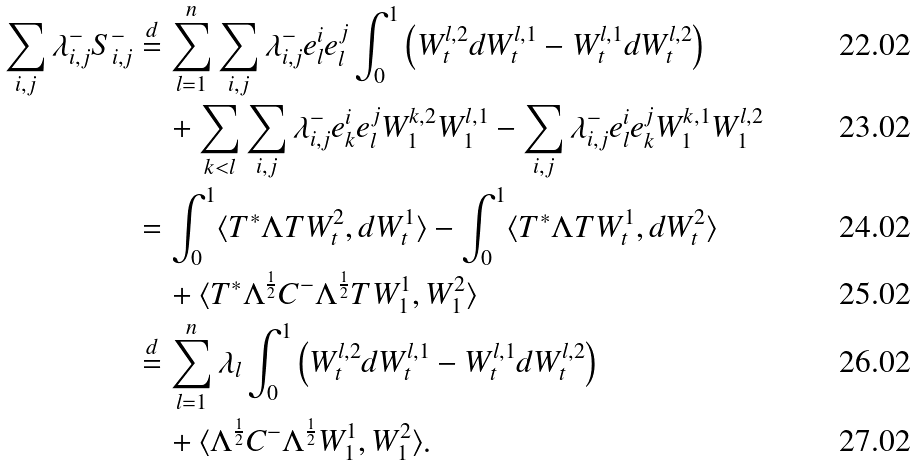<formula> <loc_0><loc_0><loc_500><loc_500>\sum _ { i , j } \lambda ^ { - } _ { i , j } S _ { i , j } ^ { - } & \overset { d } { = } \sum _ { l = 1 } ^ { n } \sum _ { i , j } \lambda ^ { - } _ { i , j } e ^ { i } _ { l } e ^ { j } _ { l } \int _ { 0 } ^ { 1 } \left ( W _ { t } ^ { l , 2 } d W _ { t } ^ { l , 1 } - W _ { t } ^ { l , 1 } d W _ { t } ^ { l , 2 } \right ) \\ & \quad + \sum _ { k < l } \sum _ { i , j } \lambda ^ { - } _ { i , j } e ^ { i } _ { k } e ^ { j } _ { l } W ^ { k , 2 } _ { 1 } W ^ { l , 1 } _ { 1 } - \sum _ { i , j } \lambda ^ { - } _ { i , j } e ^ { i } _ { l } e ^ { j } _ { k } W ^ { k , 1 } _ { 1 } W _ { 1 } ^ { l , 2 } \\ & = \int _ { 0 } ^ { 1 } \langle T ^ { * } \Lambda T W _ { t } ^ { 2 } , d W _ { t } ^ { 1 } \rangle - \int _ { 0 } ^ { 1 } \langle T ^ { * } \Lambda T W _ { t } ^ { 1 } , d W _ { t } ^ { 2 } \rangle \\ & \quad + \langle T ^ { * } \Lambda ^ { \frac { 1 } { 2 } } C ^ { - } \Lambda ^ { \frac { 1 } { 2 } } T W ^ { 1 } _ { 1 } , W ^ { 2 } _ { 1 } \rangle \\ & \overset { d } { = } \sum _ { l = 1 } ^ { n } \lambda _ { l } \int _ { 0 } ^ { 1 } \left ( W _ { t } ^ { l , 2 } d W _ { t } ^ { l , 1 } - W _ { t } ^ { l , 1 } d W _ { t } ^ { l , 2 } \right ) \\ & \quad + \langle \Lambda ^ { \frac { 1 } { 2 } } C ^ { - } \Lambda ^ { \frac { 1 } { 2 } } W ^ { 1 } _ { 1 } , W ^ { 2 } _ { 1 } \rangle .</formula> 